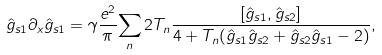Convert formula to latex. <formula><loc_0><loc_0><loc_500><loc_500>\hat { g } _ { s 1 } \partial _ { x } \hat { g } _ { s 1 } = \gamma \frac { e ^ { 2 } } { \pi } \underset { n } { \sum } \, 2 T _ { n } \frac { [ \hat { g } _ { s 1 } , \hat { g } _ { s 2 } ] } { 4 + T _ { n } ( \hat { g } _ { s 1 } \hat { g } _ { s 2 } + \hat { g } _ { s 2 } \hat { g } _ { s 1 } - 2 ) } ,</formula> 